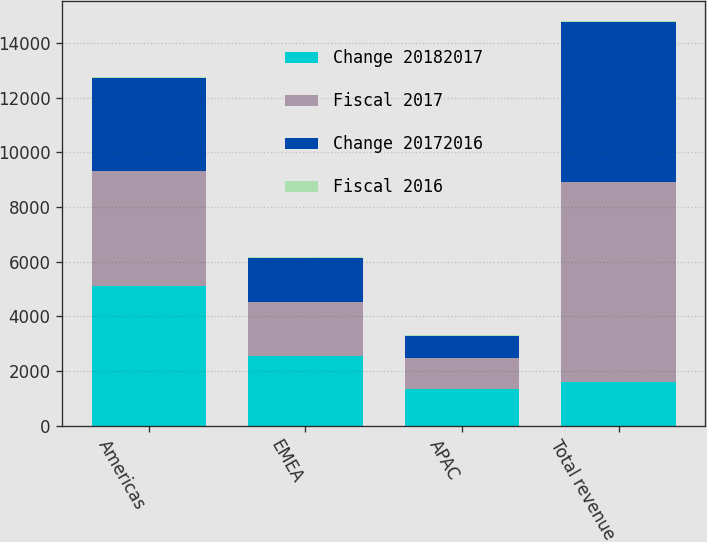Convert chart. <chart><loc_0><loc_0><loc_500><loc_500><stacked_bar_chart><ecel><fcel>Americas<fcel>EMEA<fcel>APAC<fcel>Total revenue<nl><fcel>Change 20182017<fcel>5116.8<fcel>2550<fcel>1363.2<fcel>1619.2<nl><fcel>Fiscal 2017<fcel>4216.5<fcel>1985.1<fcel>1099.9<fcel>7301.5<nl><fcel>Change 20172016<fcel>3400.1<fcel>1619.2<fcel>835.1<fcel>5854.4<nl><fcel>Fiscal 2016<fcel>21<fcel>28<fcel>24<fcel>24<nl></chart> 